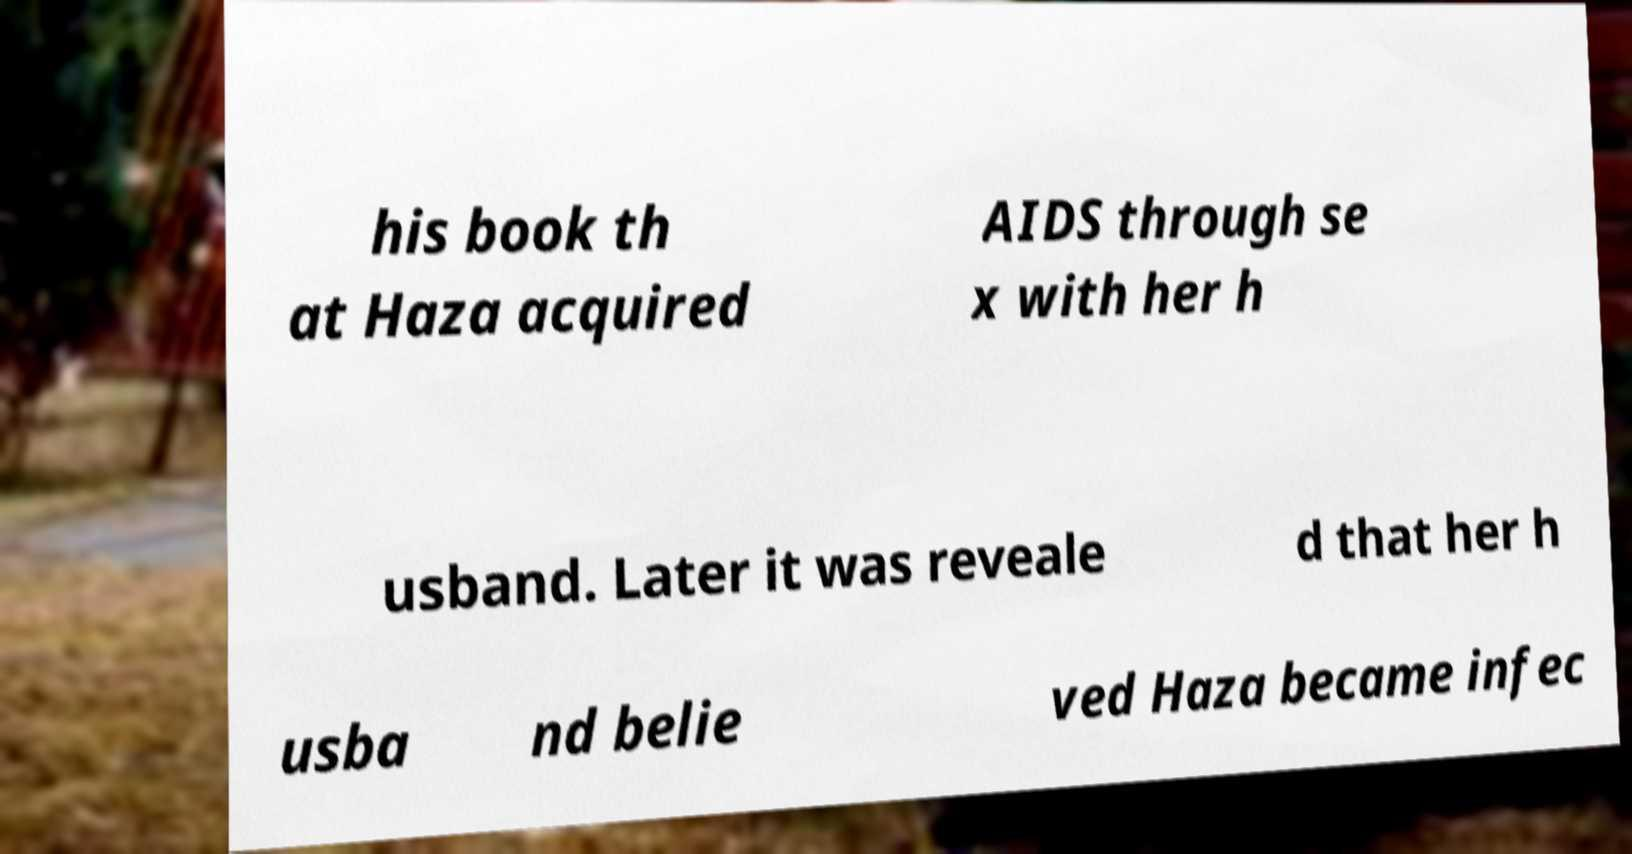Please identify and transcribe the text found in this image. his book th at Haza acquired AIDS through se x with her h usband. Later it was reveale d that her h usba nd belie ved Haza became infec 